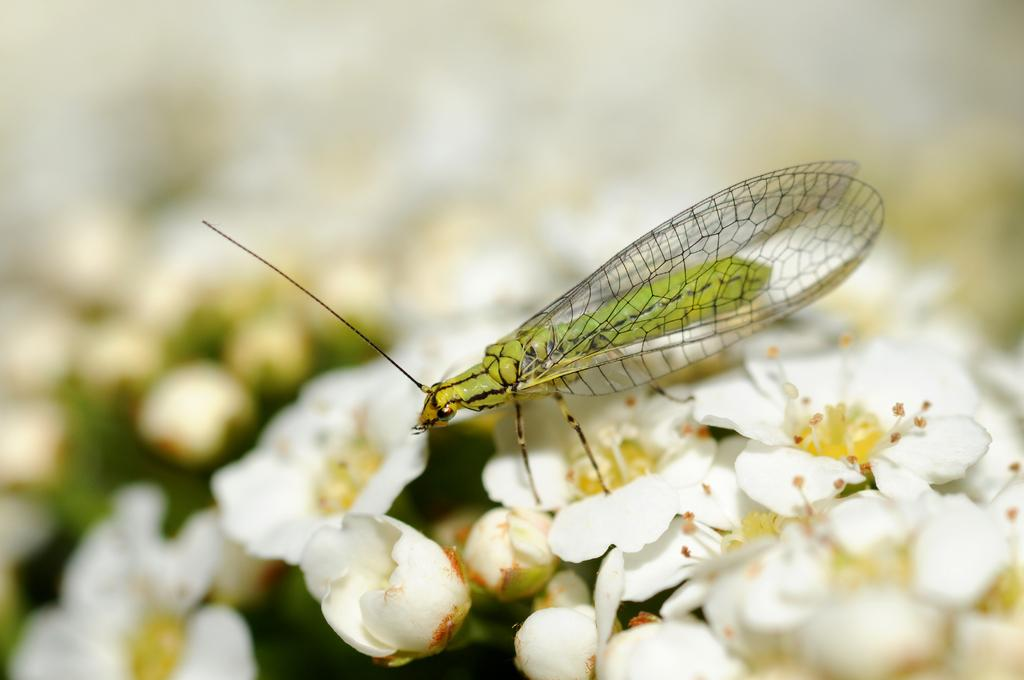What type of creature can be seen in the image? There is an insect in the image. Where is the insect located in the image? The insect is on the flowers. What type of punishment is being handed out by the secretary in the image? There is no secretary present in the image, and therefore no punishment being handed out. 